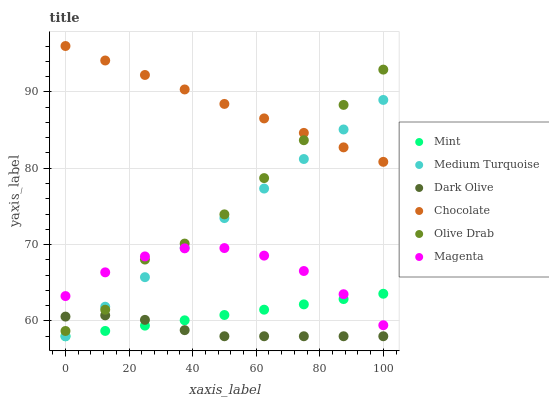Does Dark Olive have the minimum area under the curve?
Answer yes or no. Yes. Does Chocolate have the maximum area under the curve?
Answer yes or no. Yes. Does Medium Turquoise have the minimum area under the curve?
Answer yes or no. No. Does Medium Turquoise have the maximum area under the curve?
Answer yes or no. No. Is Chocolate the smoothest?
Answer yes or no. Yes. Is Olive Drab the roughest?
Answer yes or no. Yes. Is Medium Turquoise the smoothest?
Answer yes or no. No. Is Medium Turquoise the roughest?
Answer yes or no. No. Does Dark Olive have the lowest value?
Answer yes or no. Yes. Does Chocolate have the lowest value?
Answer yes or no. No. Does Chocolate have the highest value?
Answer yes or no. Yes. Does Medium Turquoise have the highest value?
Answer yes or no. No. Is Dark Olive less than Chocolate?
Answer yes or no. Yes. Is Chocolate greater than Magenta?
Answer yes or no. Yes. Does Chocolate intersect Medium Turquoise?
Answer yes or no. Yes. Is Chocolate less than Medium Turquoise?
Answer yes or no. No. Is Chocolate greater than Medium Turquoise?
Answer yes or no. No. Does Dark Olive intersect Chocolate?
Answer yes or no. No. 